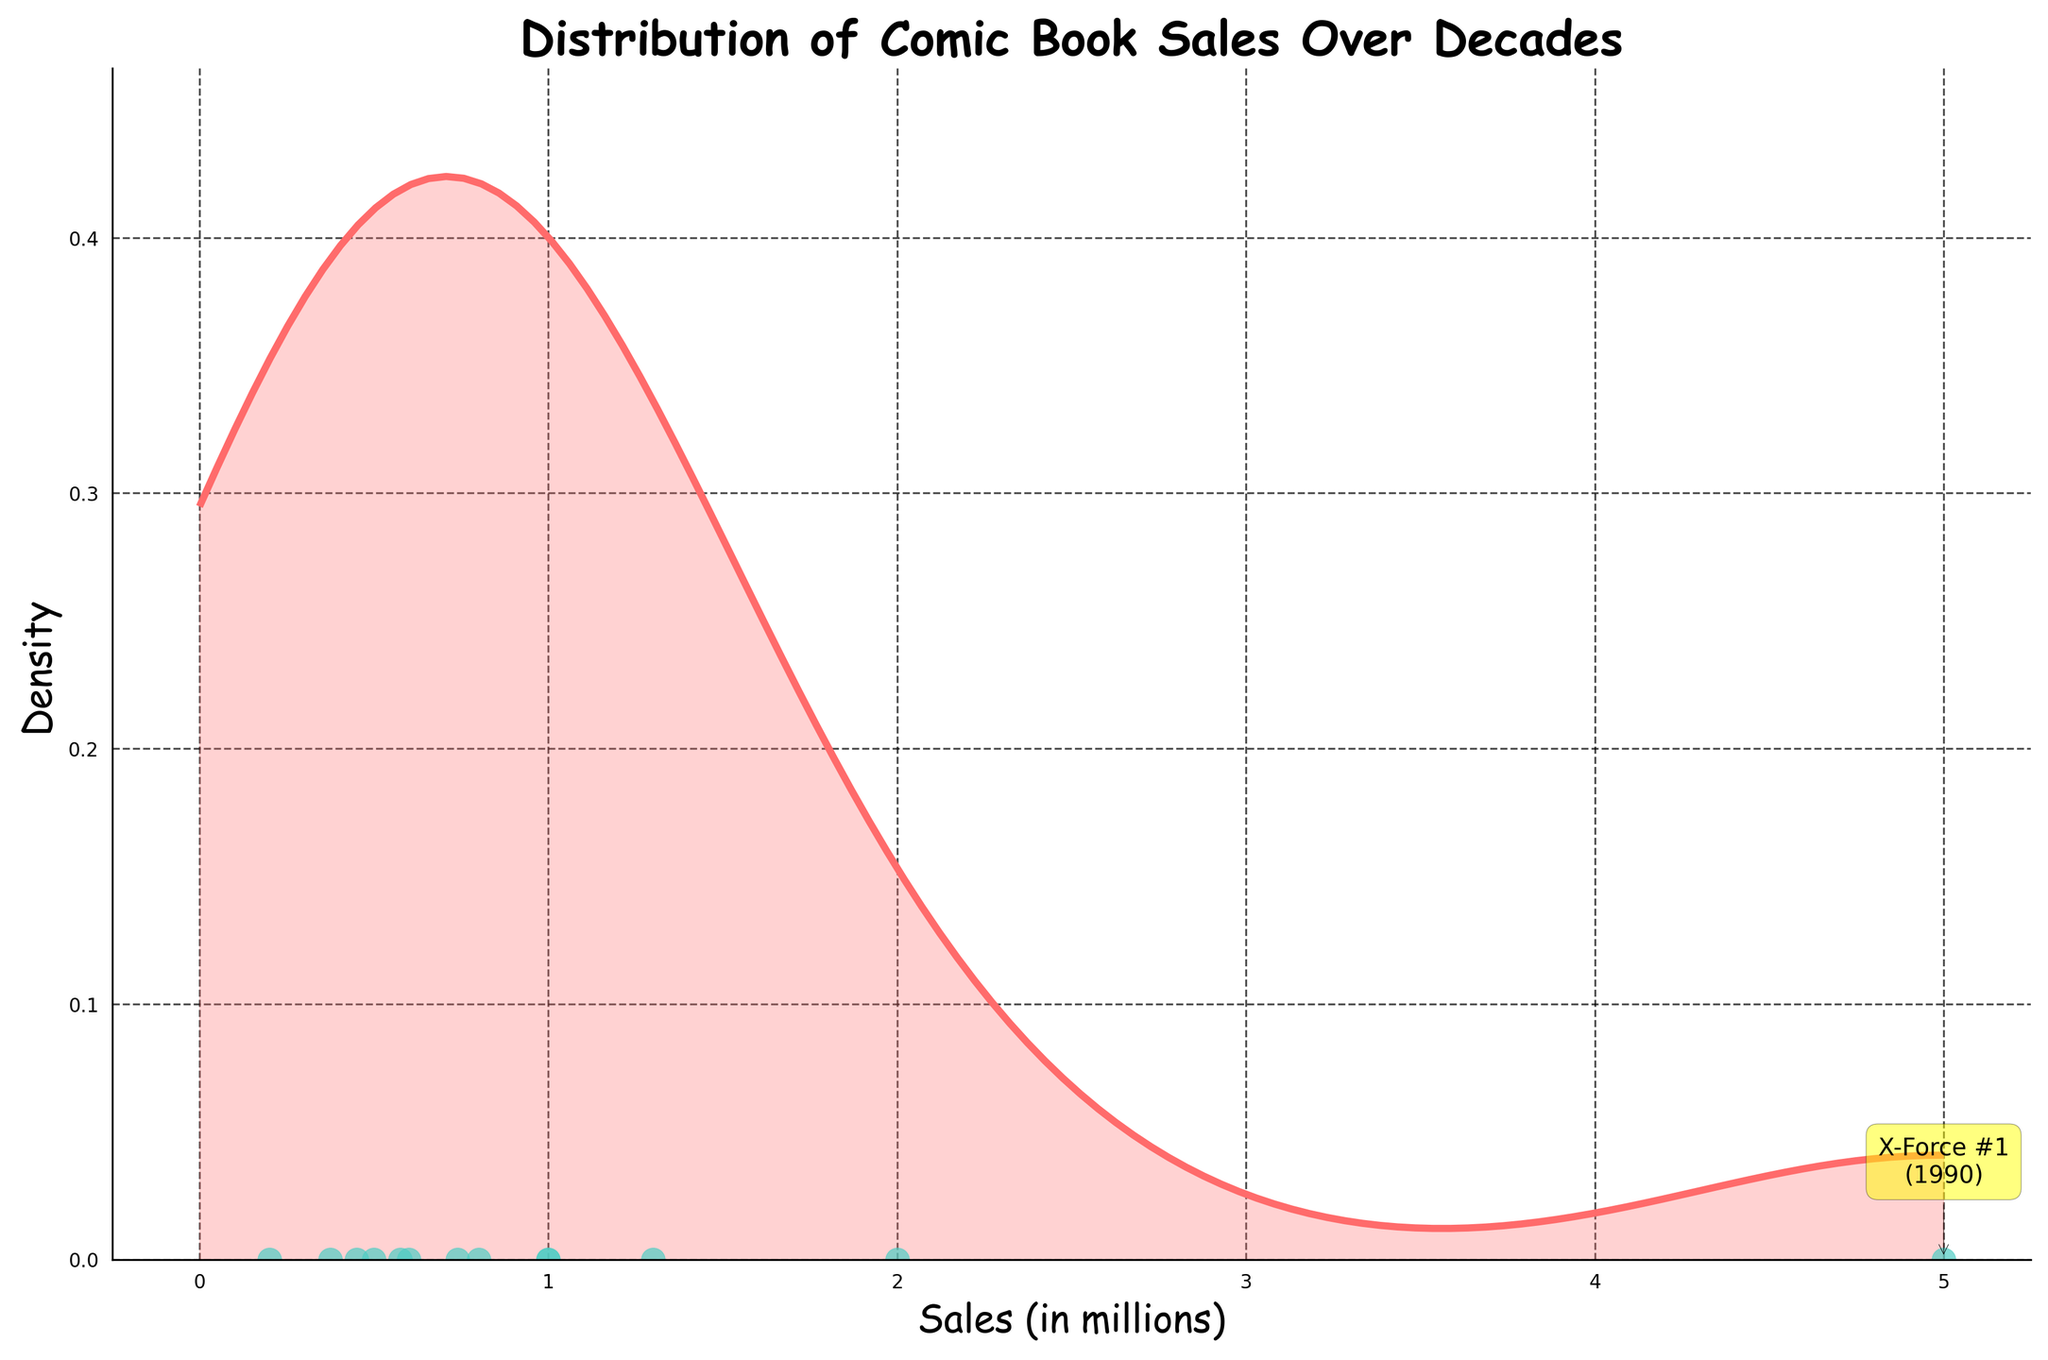What is the title of the plot? The title usually summarizes the main topic of the plot, and it is often placed at the top. In this case, you can easily see the title on the top of the plot in a bold and large font.
Answer: Distribution of Comic Book Sales Over Decades What is the color used for the scatter plot data points? The color of the scatter plot data points is different from that of the filled area under the curve. You can identify it by looking at the scatter points.
Answer: Teal How many data points are there in the plot? Each data point is represented by a dot in the scatter plot. By counting these dots, you can determine the total number of data points.
Answer: 13 Which decade has the comic book with the highest sales? Identify the data point with the highest sales (most to the right) and refer to its corresponding decade from the annotation or the visual representation.
Answer: 1990s Which issue sold the most copies and in which year? Look for the highest data point in the scatter plot and read the annotation next to it. Annotations typically provide additional information about specific points.
Answer: X-Force #1 in 1990 What is the density value at 3 million sales? Find the point where the sales value is 3 million on the x-axis and then move vertically upward to meet the density curve. Read the corresponding value on the y-axis.
Answer: Approximately 0.1 Which comic book issue marks the first notable decrease in sales on the scatter plot? Observe the scatter plot for the first significant drop in sales and identify the comic book issue associated with that data point.
Answer: The Amazing Spider-Man #1 in 1960 How does the sales distribution curve change from 1940 to 2020? Observe the shape of the density curve and the placement of the sales data points. Note any patterns or changes across different decades represented in the plot.
Answer: Decreases initially, peaks in the 1990s, then diminishes Which issues had sales greater than 1 million? Identify and list the scatter plot points that are placed above the 1-million sales mark on the x-axis and refer to their annotations.
Answer: Detective Comics #27 (1940), Superman #1 (1940), Action Comics #1 (1950), Wonder Woman #1 (1950), The Amazing Spider-Man #1 (1960), The Batman Adventures #12 (1990), X-Force #1 (1990) What is the sales value and density of Uncanny X-Men #141? Locate the data point for Uncanny X-Men #141 on the scatter plot, read its sales value from the x-axis and find the corresponding density on the y-axis.
Answer: 450,000 and approximately 0.2 